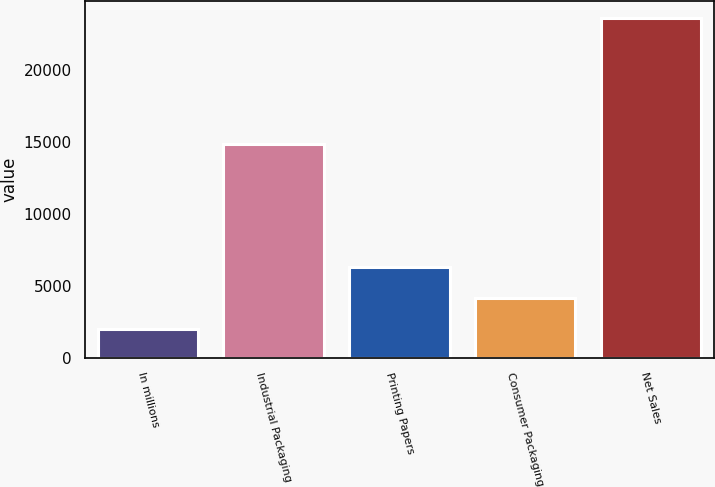Convert chart. <chart><loc_0><loc_0><loc_500><loc_500><bar_chart><fcel>In millions<fcel>Industrial Packaging<fcel>Printing Papers<fcel>Consumer Packaging<fcel>Net Sales<nl><fcel>2014<fcel>14837<fcel>6334.6<fcel>4174.3<fcel>23617<nl></chart> 